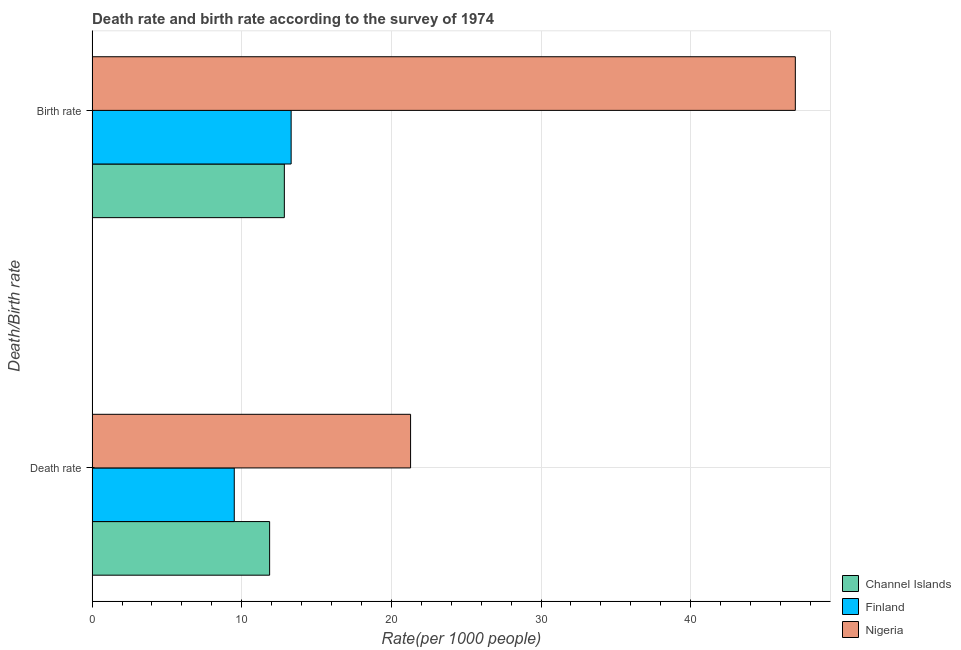How many groups of bars are there?
Your response must be concise. 2. How many bars are there on the 1st tick from the bottom?
Make the answer very short. 3. What is the label of the 1st group of bars from the top?
Offer a terse response. Birth rate. What is the birth rate in Channel Islands?
Your answer should be very brief. 12.85. Across all countries, what is the maximum death rate?
Give a very brief answer. 21.28. Across all countries, what is the minimum death rate?
Your response must be concise. 9.5. In which country was the death rate maximum?
Ensure brevity in your answer.  Nigeria. In which country was the birth rate minimum?
Your answer should be very brief. Channel Islands. What is the total death rate in the graph?
Provide a succinct answer. 42.64. What is the difference between the birth rate in Finland and that in Nigeria?
Offer a very short reply. -33.69. What is the difference between the death rate in Channel Islands and the birth rate in Finland?
Your answer should be compact. -1.44. What is the average death rate per country?
Keep it short and to the point. 14.21. What is the difference between the death rate and birth rate in Nigeria?
Ensure brevity in your answer.  -25.71. In how many countries, is the birth rate greater than 2 ?
Offer a very short reply. 3. What is the ratio of the death rate in Channel Islands to that in Nigeria?
Make the answer very short. 0.56. In how many countries, is the death rate greater than the average death rate taken over all countries?
Make the answer very short. 1. What does the 3rd bar from the top in Death rate represents?
Give a very brief answer. Channel Islands. What does the 3rd bar from the bottom in Birth rate represents?
Ensure brevity in your answer.  Nigeria. How are the legend labels stacked?
Ensure brevity in your answer.  Vertical. What is the title of the graph?
Your answer should be compact. Death rate and birth rate according to the survey of 1974. Does "Pacific island small states" appear as one of the legend labels in the graph?
Ensure brevity in your answer.  No. What is the label or title of the X-axis?
Your answer should be very brief. Rate(per 1000 people). What is the label or title of the Y-axis?
Your answer should be compact. Death/Birth rate. What is the Rate(per 1000 people) of Channel Islands in Death rate?
Ensure brevity in your answer.  11.86. What is the Rate(per 1000 people) of Nigeria in Death rate?
Provide a succinct answer. 21.28. What is the Rate(per 1000 people) in Channel Islands in Birth rate?
Make the answer very short. 12.85. What is the Rate(per 1000 people) of Nigeria in Birth rate?
Keep it short and to the point. 46.99. Across all Death/Birth rate, what is the maximum Rate(per 1000 people) in Channel Islands?
Give a very brief answer. 12.85. Across all Death/Birth rate, what is the maximum Rate(per 1000 people) of Nigeria?
Keep it short and to the point. 46.99. Across all Death/Birth rate, what is the minimum Rate(per 1000 people) of Channel Islands?
Give a very brief answer. 11.86. Across all Death/Birth rate, what is the minimum Rate(per 1000 people) in Nigeria?
Provide a short and direct response. 21.28. What is the total Rate(per 1000 people) of Channel Islands in the graph?
Provide a short and direct response. 24.71. What is the total Rate(per 1000 people) of Finland in the graph?
Give a very brief answer. 22.8. What is the total Rate(per 1000 people) in Nigeria in the graph?
Provide a short and direct response. 68.27. What is the difference between the Rate(per 1000 people) of Channel Islands in Death rate and that in Birth rate?
Offer a terse response. -0.98. What is the difference between the Rate(per 1000 people) in Nigeria in Death rate and that in Birth rate?
Offer a very short reply. -25.71. What is the difference between the Rate(per 1000 people) in Channel Islands in Death rate and the Rate(per 1000 people) in Finland in Birth rate?
Your response must be concise. -1.44. What is the difference between the Rate(per 1000 people) in Channel Islands in Death rate and the Rate(per 1000 people) in Nigeria in Birth rate?
Your answer should be very brief. -35.13. What is the difference between the Rate(per 1000 people) in Finland in Death rate and the Rate(per 1000 people) in Nigeria in Birth rate?
Provide a succinct answer. -37.49. What is the average Rate(per 1000 people) in Channel Islands per Death/Birth rate?
Provide a short and direct response. 12.35. What is the average Rate(per 1000 people) in Finland per Death/Birth rate?
Provide a succinct answer. 11.4. What is the average Rate(per 1000 people) in Nigeria per Death/Birth rate?
Your response must be concise. 34.14. What is the difference between the Rate(per 1000 people) of Channel Islands and Rate(per 1000 people) of Finland in Death rate?
Offer a terse response. 2.36. What is the difference between the Rate(per 1000 people) in Channel Islands and Rate(per 1000 people) in Nigeria in Death rate?
Your response must be concise. -9.42. What is the difference between the Rate(per 1000 people) of Finland and Rate(per 1000 people) of Nigeria in Death rate?
Your answer should be very brief. -11.78. What is the difference between the Rate(per 1000 people) in Channel Islands and Rate(per 1000 people) in Finland in Birth rate?
Keep it short and to the point. -0.45. What is the difference between the Rate(per 1000 people) in Channel Islands and Rate(per 1000 people) in Nigeria in Birth rate?
Give a very brief answer. -34.15. What is the difference between the Rate(per 1000 people) in Finland and Rate(per 1000 people) in Nigeria in Birth rate?
Give a very brief answer. -33.69. What is the ratio of the Rate(per 1000 people) of Channel Islands in Death rate to that in Birth rate?
Provide a succinct answer. 0.92. What is the ratio of the Rate(per 1000 people) in Nigeria in Death rate to that in Birth rate?
Provide a succinct answer. 0.45. What is the difference between the highest and the second highest Rate(per 1000 people) in Nigeria?
Offer a very short reply. 25.71. What is the difference between the highest and the lowest Rate(per 1000 people) of Channel Islands?
Your answer should be compact. 0.98. What is the difference between the highest and the lowest Rate(per 1000 people) in Nigeria?
Make the answer very short. 25.71. 